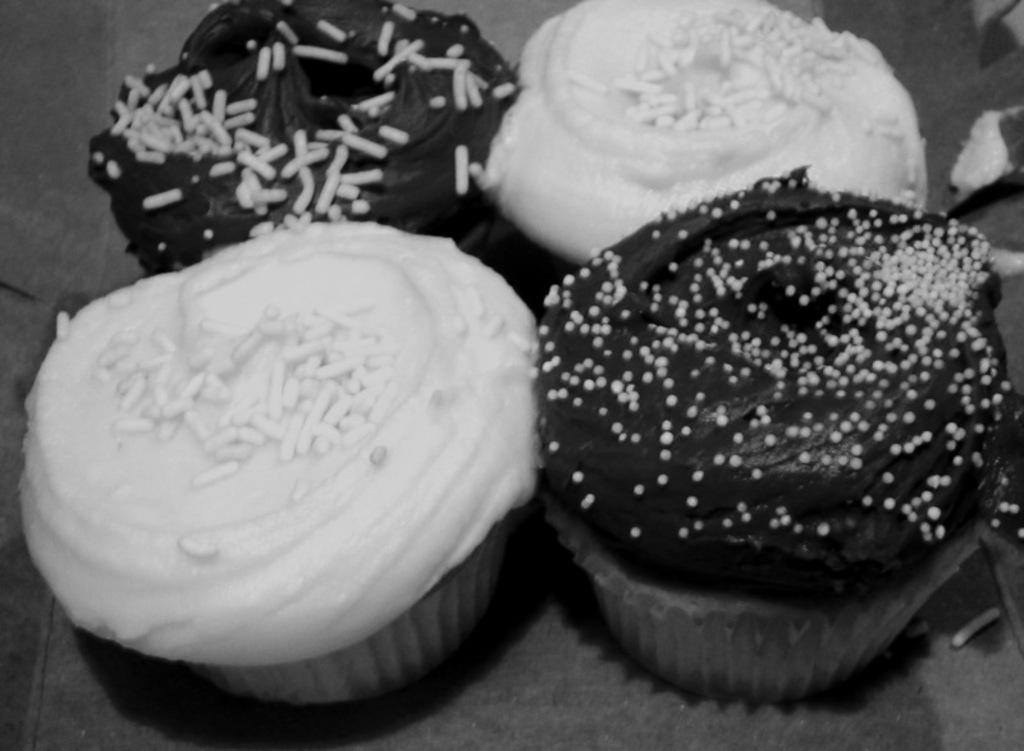Please provide a concise description of this image. In this picture I can see 4 cupcakes in front and I see that this is a black and white image. 